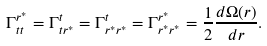Convert formula to latex. <formula><loc_0><loc_0><loc_500><loc_500>\Gamma ^ { r ^ { \ast } } _ { t t } = \Gamma ^ { t } _ { t r ^ { \ast } } = \Gamma ^ { t } _ { r ^ { \ast } r ^ { \ast } } = \Gamma ^ { r ^ { \ast } } _ { r ^ { \ast } r ^ { \ast } } = \frac { 1 } { 2 } \frac { d \Omega ( r ) } { d r } .</formula> 